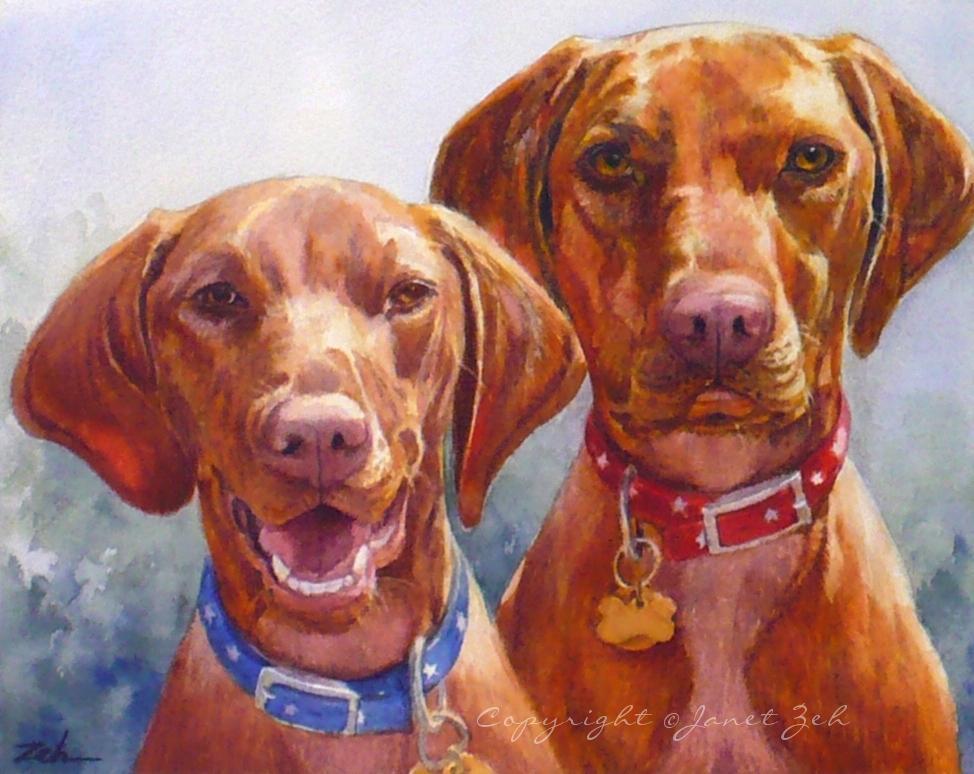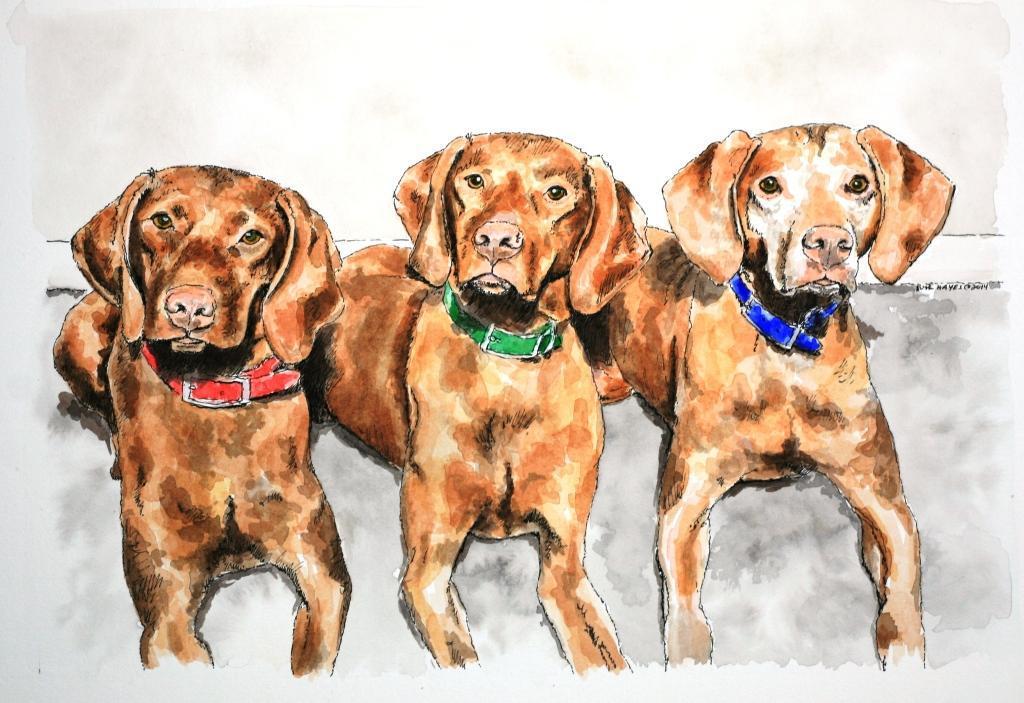The first image is the image on the left, the second image is the image on the right. Assess this claim about the two images: "There are three dog in a row with different color collars on.". Correct or not? Answer yes or no. Yes. The first image is the image on the left, the second image is the image on the right. Considering the images on both sides, is "There are more dogs in the image on the right." valid? Answer yes or no. Yes. 